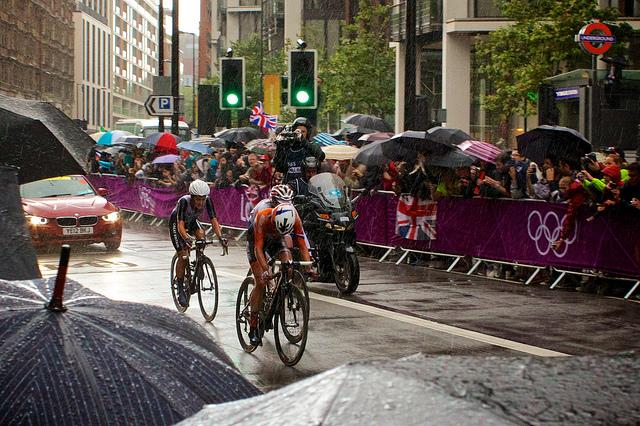What color are the traffic lights?
Write a very short answer. Green. What city is this?
Write a very short answer. London. What organization's logo is on the purple banner?
Write a very short answer. Olympics. 